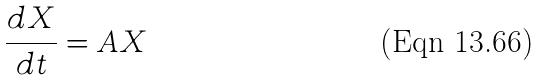<formula> <loc_0><loc_0><loc_500><loc_500>\frac { d X } { d t } = A X</formula> 